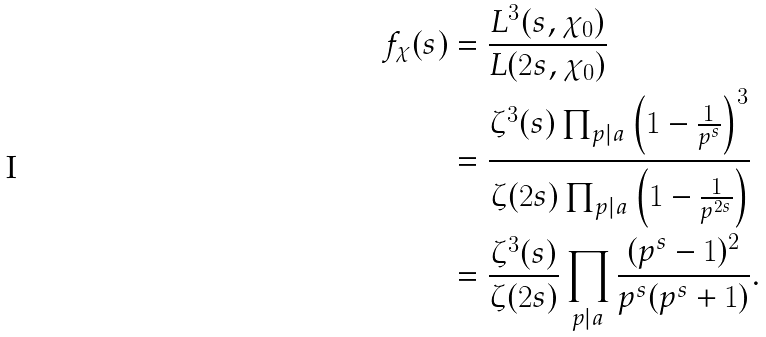Convert formula to latex. <formula><loc_0><loc_0><loc_500><loc_500>f _ { \chi } ( s ) & = \frac { L ^ { 3 } ( s , \chi _ { 0 } ) } { L ( 2 s , \chi _ { 0 } ) } \\ & = \frac { \zeta ^ { 3 } ( s ) \prod _ { p | a } \left ( 1 - \frac { 1 } { p ^ { s } } \right ) ^ { 3 } } { \zeta ( 2 s ) \prod _ { p | a } \left ( 1 - \frac { 1 } { p ^ { 2 s } } \right ) } \\ & = \frac { \zeta ^ { 3 } ( s ) } { \zeta ( 2 s ) } \prod _ { p | a } \frac { ( p ^ { s } - 1 ) ^ { 2 } } { p ^ { s } ( p ^ { s } + 1 ) } .</formula> 